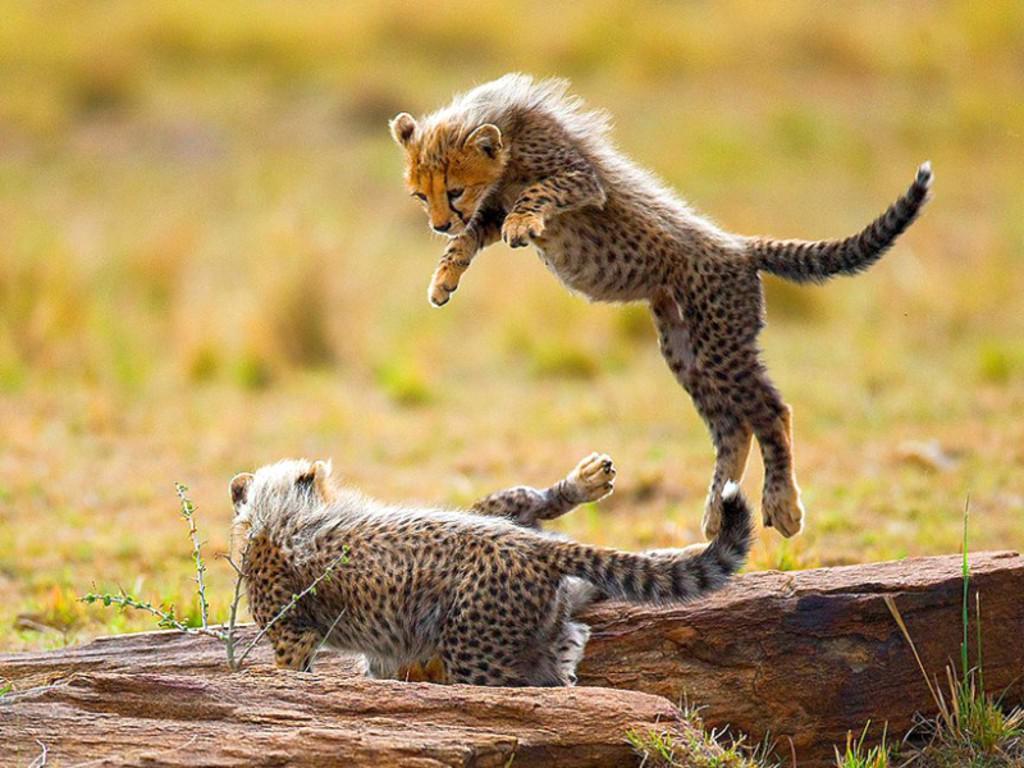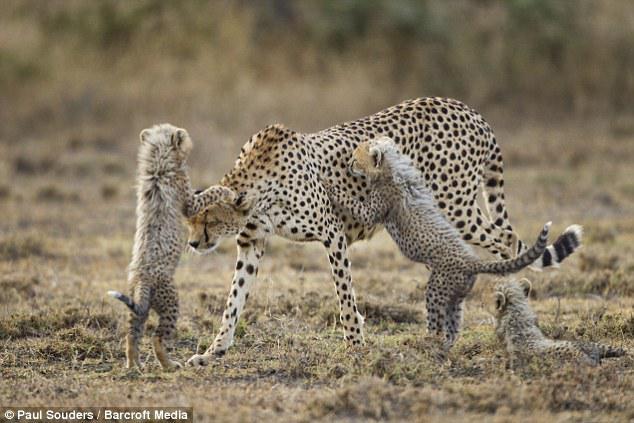The first image is the image on the left, the second image is the image on the right. For the images shown, is this caption "A spotted wild kitten with its tail extending upward is about to pounce on another kitten in one image." true? Answer yes or no. Yes. The first image is the image on the left, the second image is the image on the right. For the images shown, is this caption "One of the images features a young cat leaping into the air to pounce on another cat." true? Answer yes or no. Yes. 